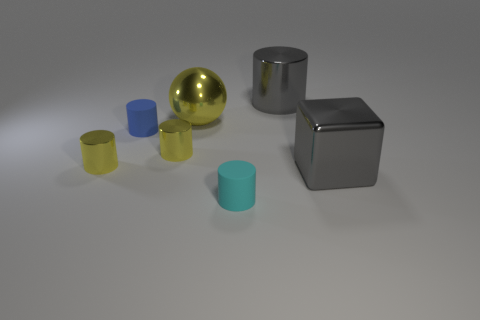What number of gray things are large metal cylinders or cubes?
Your response must be concise. 2. How many other objects are there of the same size as the blue object?
Give a very brief answer. 3. What number of tiny things are yellow things or brown metallic things?
Ensure brevity in your answer.  2. There is a gray shiny block; is it the same size as the blue rubber cylinder that is on the left side of the large cylinder?
Keep it short and to the point. No. What number of other things are the same shape as the cyan rubber object?
Your answer should be very brief. 4. What shape is the big gray object that is the same material as the large gray block?
Make the answer very short. Cylinder. Are any small yellow metallic cylinders visible?
Your response must be concise. Yes. Is the number of tiny yellow cylinders that are on the right side of the small cyan cylinder less than the number of tiny cyan cylinders that are behind the metallic block?
Keep it short and to the point. No. The large shiny thing on the left side of the big gray metal cylinder has what shape?
Your response must be concise. Sphere. Does the gray cylinder have the same material as the sphere?
Ensure brevity in your answer.  Yes. 